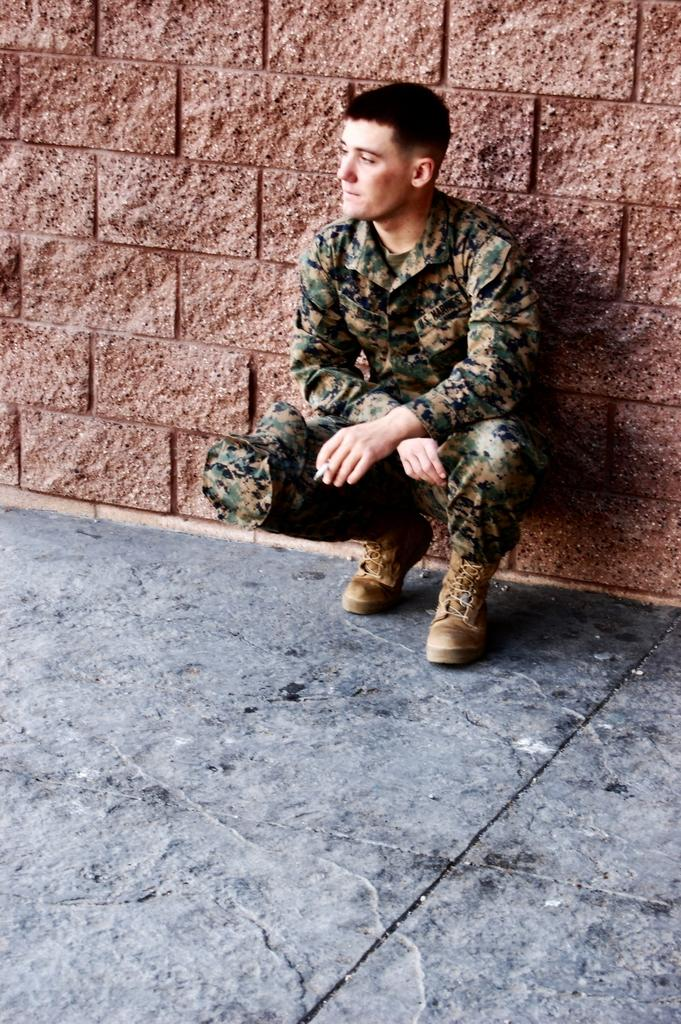Who or what is the main subject in the image? There is a person in the image. What is behind the person in the image? The person is in front of a wall. What is the person wearing in the image? The person is wearing clothes and shoes. What type of waves can be seen crashing against the shore in the image? There are no waves or shore visible in the image; it features a person in front of a wall. How many crows are perched on the wall in the image? There are no crows present in the image; it features a person in front of a wall. 